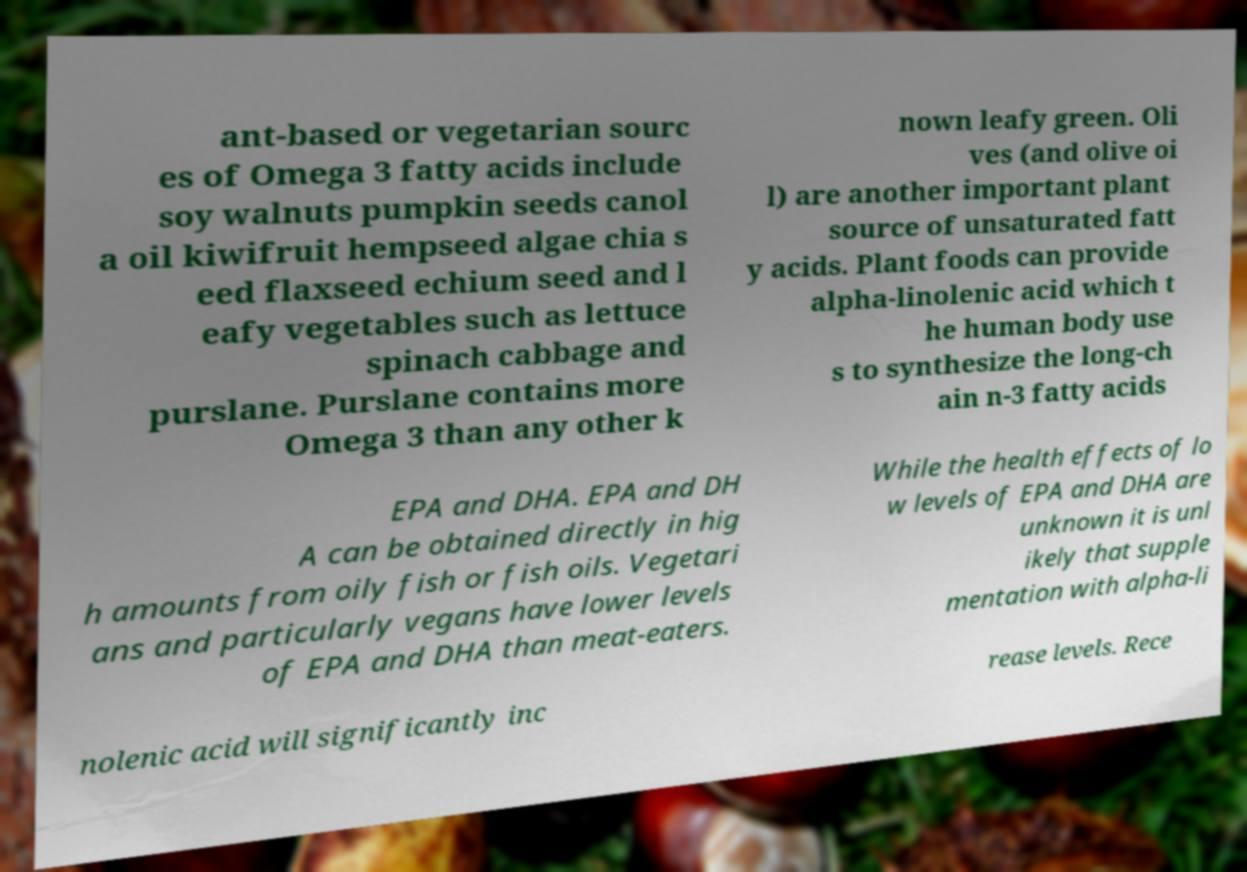Please identify and transcribe the text found in this image. ant-based or vegetarian sourc es of Omega 3 fatty acids include soy walnuts pumpkin seeds canol a oil kiwifruit hempseed algae chia s eed flaxseed echium seed and l eafy vegetables such as lettuce spinach cabbage and purslane. Purslane contains more Omega 3 than any other k nown leafy green. Oli ves (and olive oi l) are another important plant source of unsaturated fatt y acids. Plant foods can provide alpha-linolenic acid which t he human body use s to synthesize the long-ch ain n-3 fatty acids EPA and DHA. EPA and DH A can be obtained directly in hig h amounts from oily fish or fish oils. Vegetari ans and particularly vegans have lower levels of EPA and DHA than meat-eaters. While the health effects of lo w levels of EPA and DHA are unknown it is unl ikely that supple mentation with alpha-li nolenic acid will significantly inc rease levels. Rece 